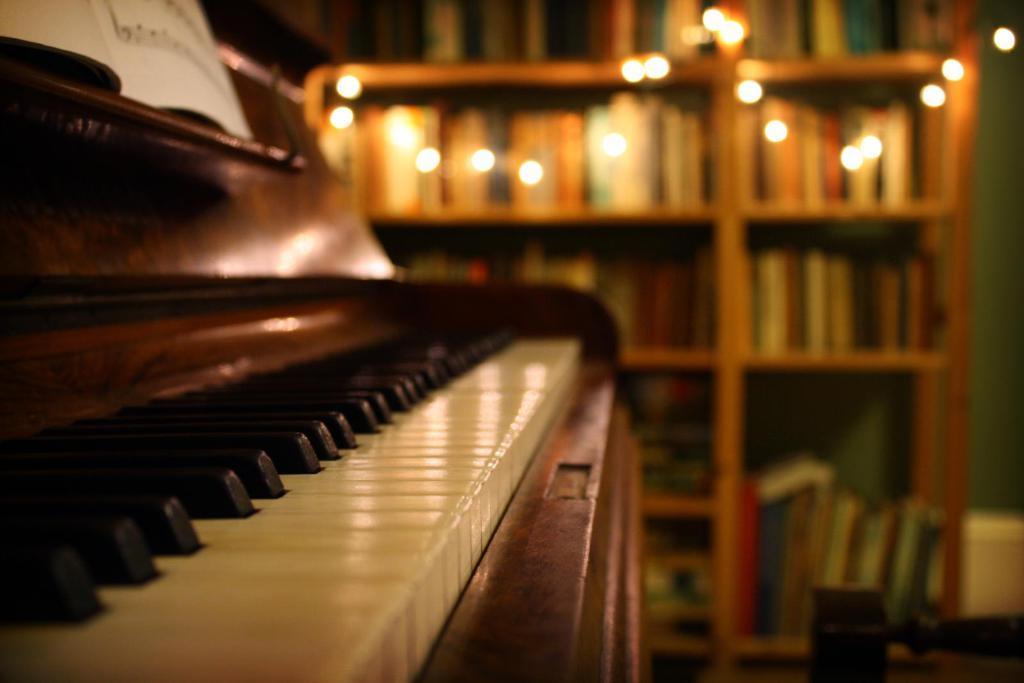How would you summarize this image in a sentence or two? In this image I can see a musical instrument. In the background I can see lights as decoration. 